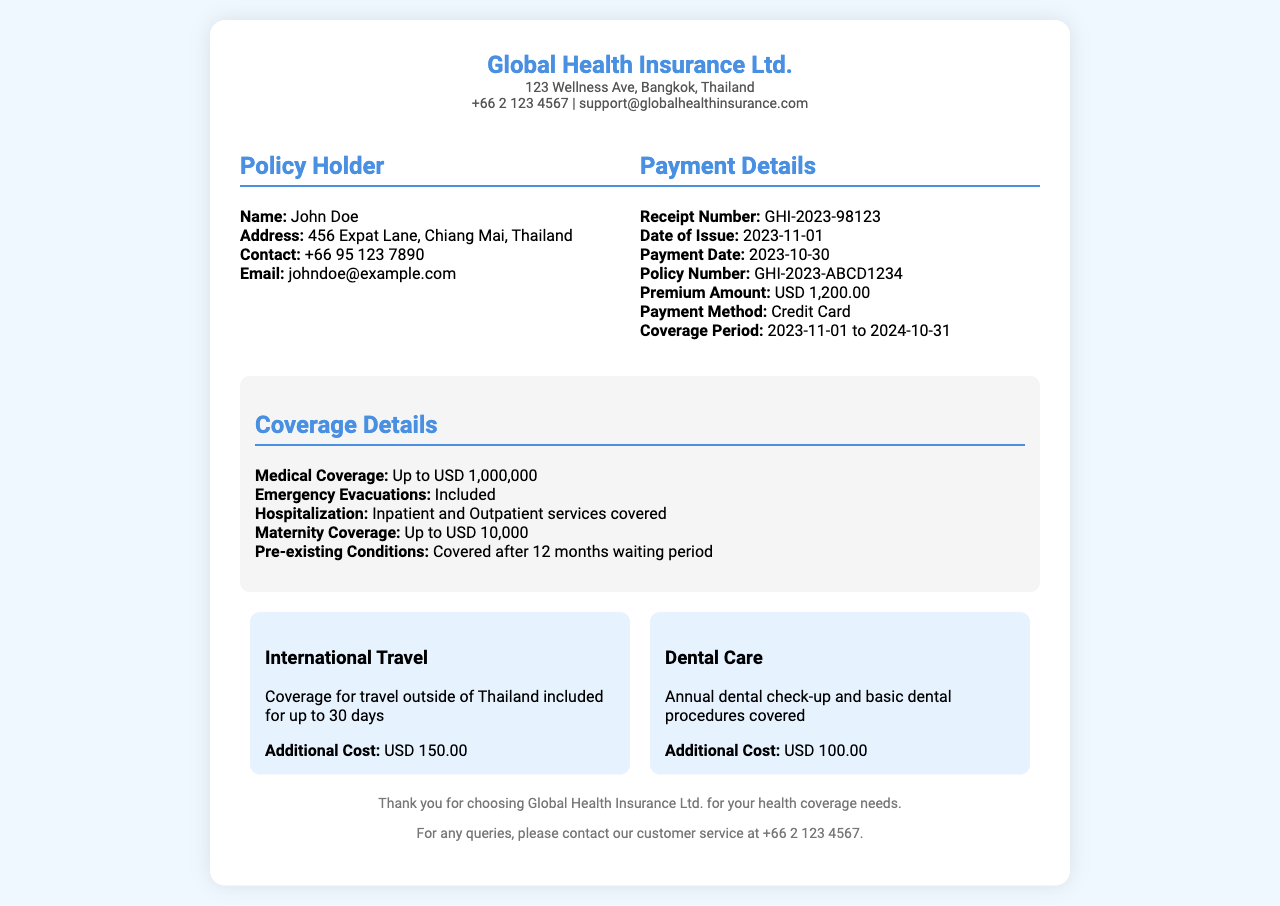What is the receipt number? The receipt number is specifically mentioned under the payment details section of the document.
Answer: GHI-2023-98123 What is the premium amount? The premium amount is stated in the payment details section.
Answer: USD 1,200.00 What date was the payment made? The payment date is given in the payment details section.
Answer: 2023-10-30 What is the coverage period? The coverage period is explicitly indicated under payment details.
Answer: 2023-11-01 to 2024-10-31 How much is the maternity coverage? The maternity coverage amount is specified in the coverage details section.
Answer: Up to USD 10,000 How long is the coverage for international travel? The duration is detailed in the endorsements section regarding international travel coverage.
Answer: Up to 30 days What is included in the hospitalization coverage? The nature of hospitalization coverage is explained in the coverage details section.
Answer: Inpatient and Outpatient services covered What is the additional cost for dental care? The additional cost for dental care is mentioned in the endorsements section.
Answer: USD 100.00 Which company's logo is displayed at the top? The company's name is shown prominently as the logo in the header.
Answer: Global Health Insurance Ltd How long is the waiting period for pre-existing conditions to be covered? The waiting period for pre-existing conditions is noted in the coverage details section.
Answer: 12 months waiting period 